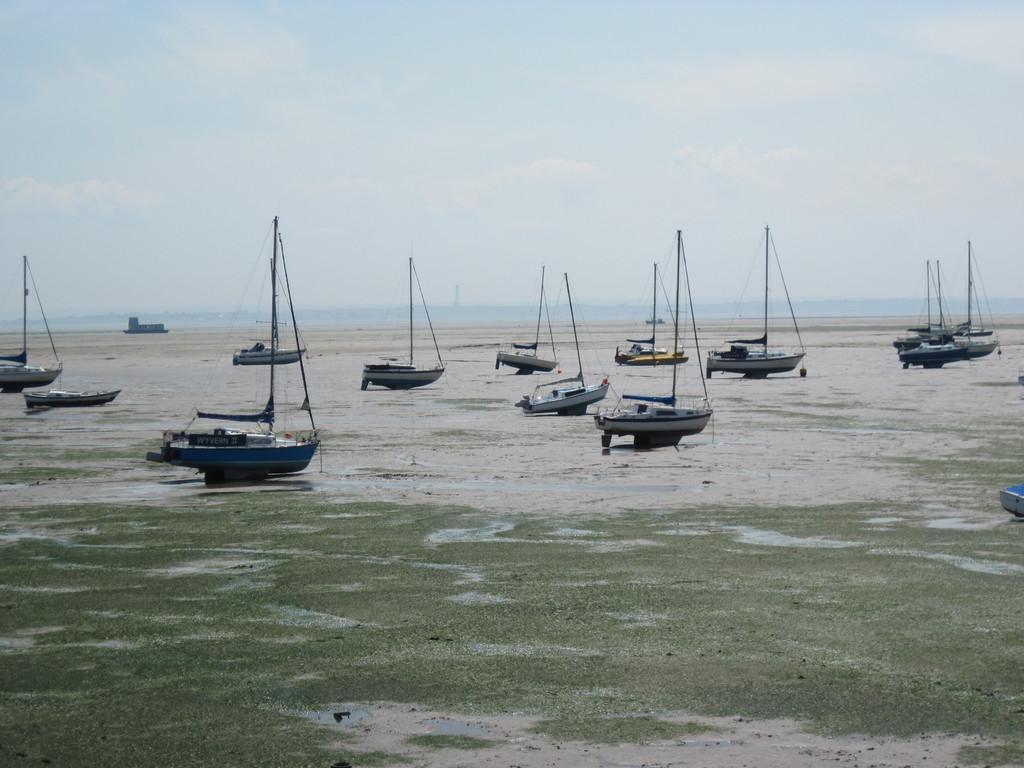Can you describe this image briefly? This image consists of many boards kept on the ground. At the bottom, there is ground. In the background, there is water. At the top, there is a sky. 